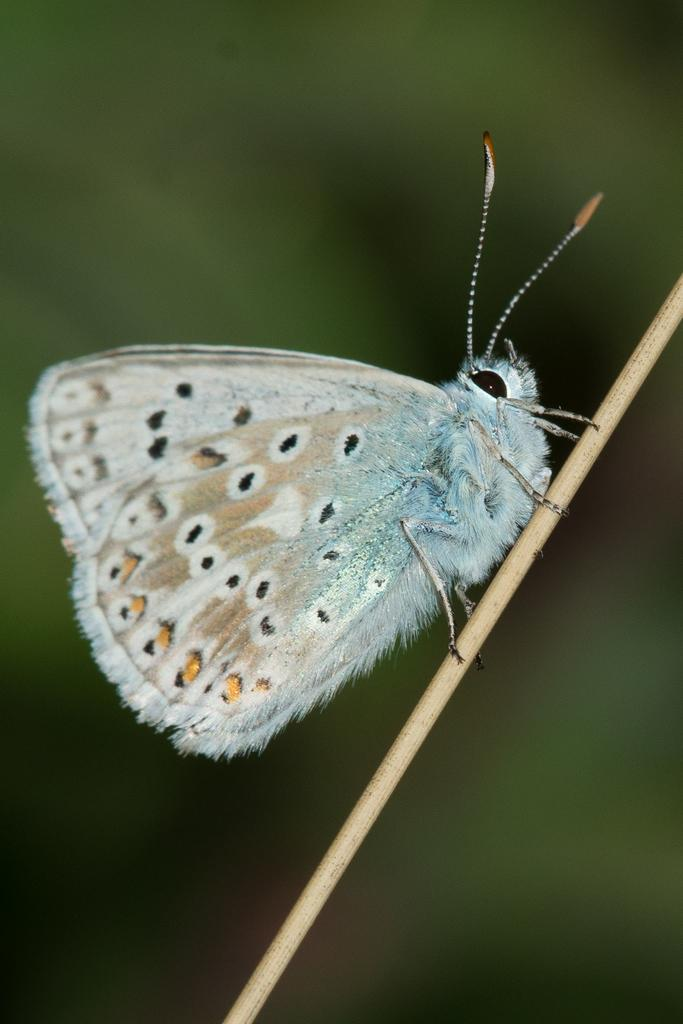What is the main subject of the image? There is a butterfly in the image. How is the butterfly positioned in the image? The butterfly is on a stick. Can you describe the background of the image? The background of the image is blurry. What type of root can be seen growing from the butterfly's wings in the image? There is no root growing from the butterfly's wings in the image; it is simply a butterfly on a stick. How does the clam contribute to the acoustics of the image? There is no clam present in the image, so it cannot contribute to the acoustics. 